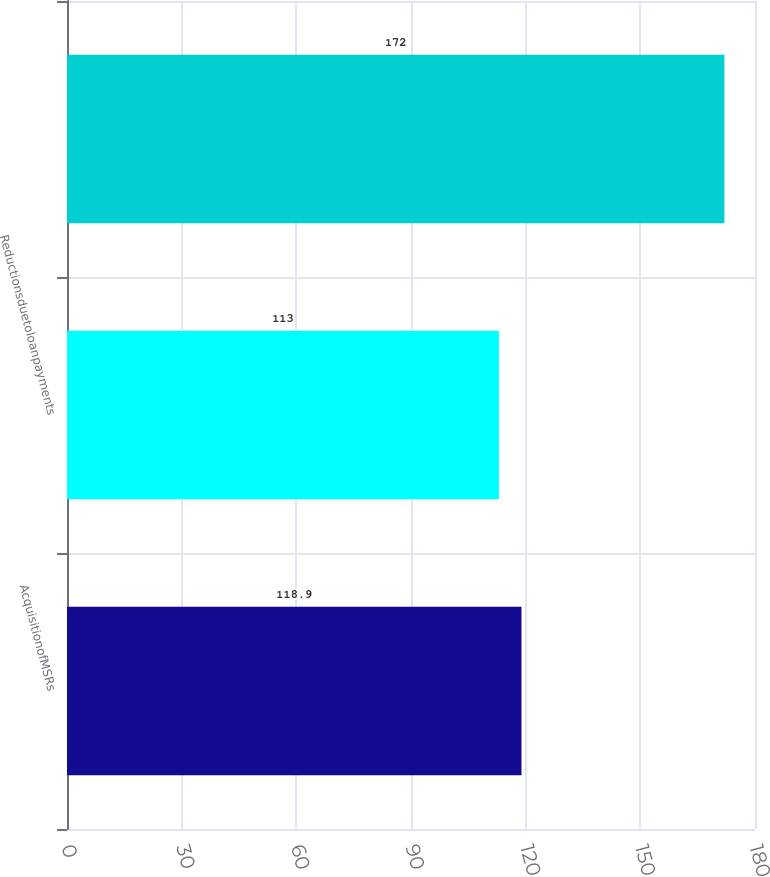<chart> <loc_0><loc_0><loc_500><loc_500><bar_chart><fcel>AcquisitionofMSRs<fcel>Reductionsduetoloanpayments<fcel>Unnamed: 2<nl><fcel>118.9<fcel>113<fcel>172<nl></chart> 